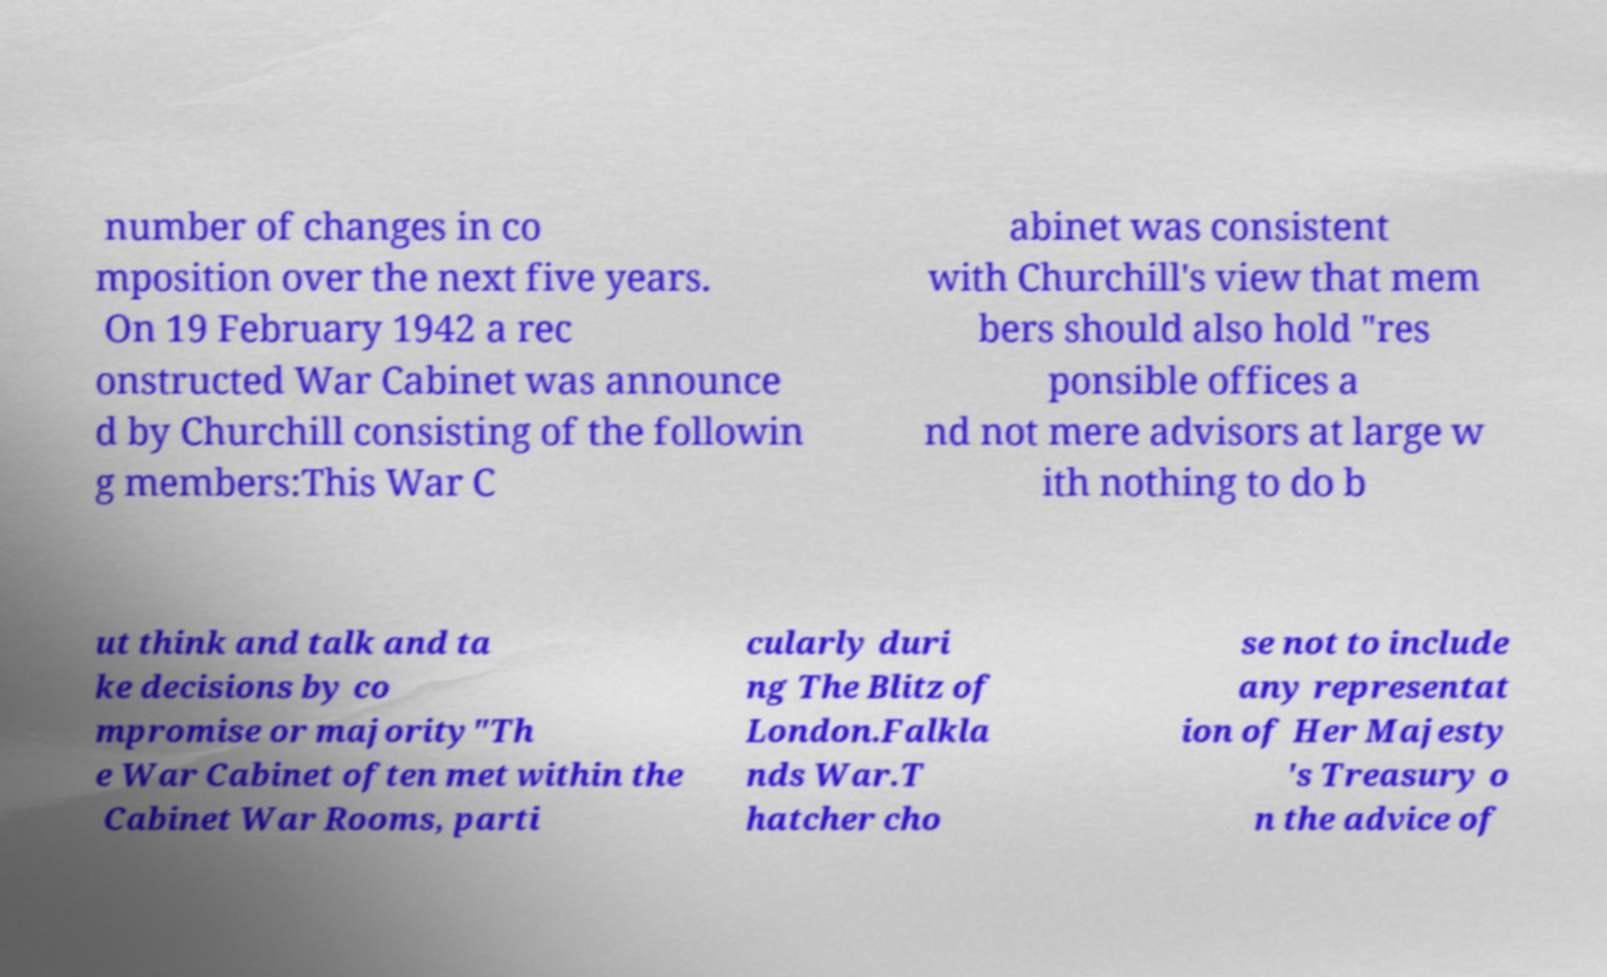Could you extract and type out the text from this image? number of changes in co mposition over the next five years. On 19 February 1942 a rec onstructed War Cabinet was announce d by Churchill consisting of the followin g members:This War C abinet was consistent with Churchill's view that mem bers should also hold "res ponsible offices a nd not mere advisors at large w ith nothing to do b ut think and talk and ta ke decisions by co mpromise or majority"Th e War Cabinet often met within the Cabinet War Rooms, parti cularly duri ng The Blitz of London.Falkla nds War.T hatcher cho se not to include any representat ion of Her Majesty 's Treasury o n the advice of 